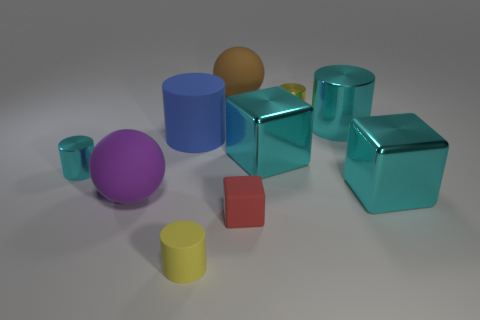There is a blue rubber cylinder that is behind the tiny matte object that is behind the yellow rubber cylinder; is there a large thing that is behind it?
Offer a terse response. Yes. The ball that is in front of the big brown matte object that is behind the big metallic thing that is on the right side of the large cyan cylinder is what color?
Your response must be concise. Purple. What is the material of the blue object that is the same shape as the yellow rubber thing?
Provide a succinct answer. Rubber. There is a rubber ball that is behind the tiny metallic thing on the right side of the brown rubber ball; how big is it?
Give a very brief answer. Large. There is a cyan block left of the yellow metal thing; what is it made of?
Provide a succinct answer. Metal. The purple thing that is made of the same material as the small red object is what size?
Ensure brevity in your answer.  Large. What number of other rubber objects are the same shape as the purple thing?
Your answer should be very brief. 1. There is a big brown matte object; is it the same shape as the small yellow object right of the small red rubber thing?
Your answer should be compact. No. There is a thing that is the same color as the small rubber cylinder; what shape is it?
Your answer should be compact. Cylinder. Are there any big cyan cubes that have the same material as the small cube?
Offer a very short reply. No. 